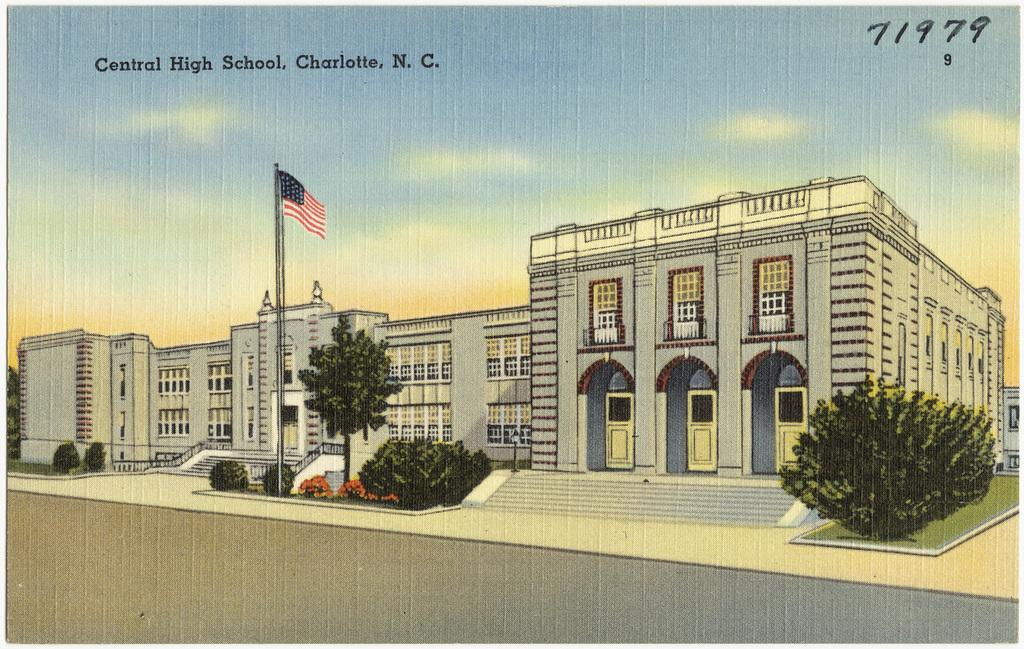What can be seen in the sky in the image? The sky is visible in the image. What is written at the top portion of the image? There is text written at the top portion of the image. What type of building is in the image? There is a school building in the image. What type of vegetation is present in the image? Plants, trees, and grass are present in the image. Are there any architectural features in the image? Yes, there are stairs in the image. What is the symbolic object visible in the image? There is a flag in the image. What type of zipper can be seen on the school building in the image? There is no zipper present on the school building in the image. What type of operation is being performed on the plants in the image? There is no operation being performed on the plants in the image; they are simply present. 